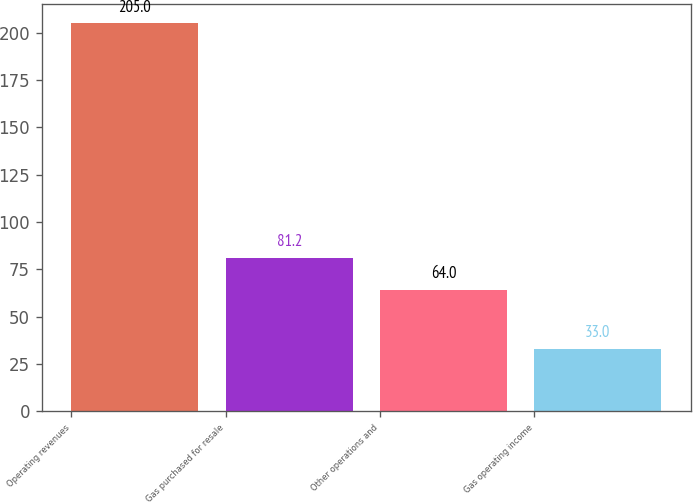<chart> <loc_0><loc_0><loc_500><loc_500><bar_chart><fcel>Operating revenues<fcel>Gas purchased for resale<fcel>Other operations and<fcel>Gas operating income<nl><fcel>205<fcel>81.2<fcel>64<fcel>33<nl></chart> 